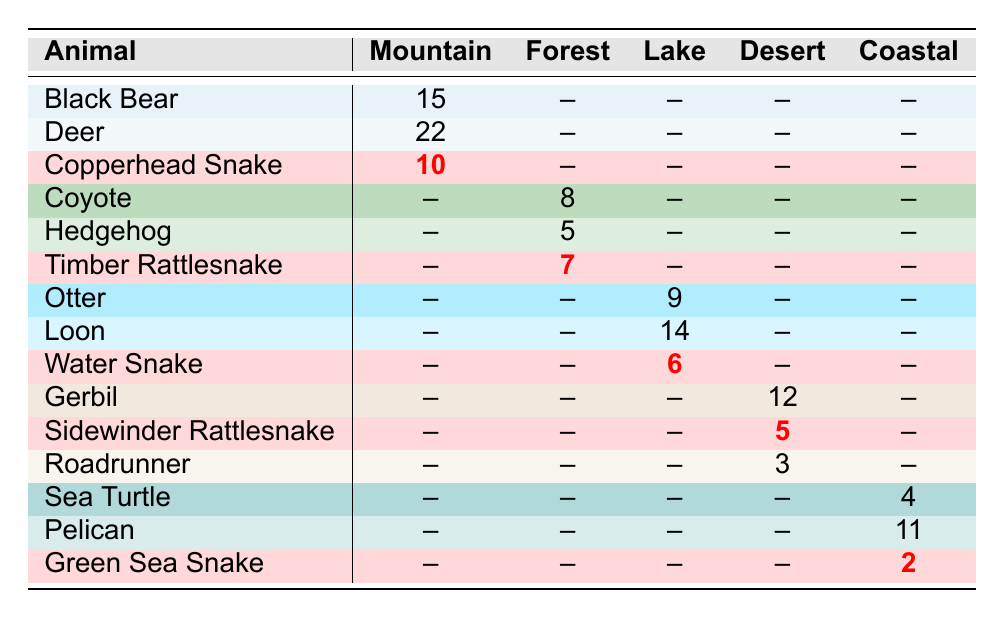What is the highest number of encounters with any type of animal in the Mountain terrain? According to the table, the highest encounter count in the Mountain terrain is 22 for Deer.
Answer: 22 How many encounters with snakes were reported in total across all terrains? The encounters with snakes are 10 (Copperhead Snake), 7 (Timber Rattlesnake), 6 (Water Snake), 5 (Sidewinder Rattlesnake), and 2 (Green Sea Snake). Summing these gives a total of 30 snake encounters.
Answer: 30 Is the encounter count for the Coyote in the Forest terrain greater than the encounter count for the Otter in the Lake terrain? The table shows 8 encounters with Coyote and 9 encounters with Otter. Since 8 is less than 9, the statement is false.
Answer: No What is the total number of animal encounters reported in the Lake terrain? The table lists 9 encounters with Otter and 14 encounters with Loon (Water Snake is not part of this terrain). Adding these gives a total of 23 encounters in the Lake terrain.
Answer: 23 How many more encounters were reported for Deer in the Mountain terrain compared to Hedgehog in the Forest terrain? The encounter counts show 22 for Deer and 5 for Hedgehog. The difference is 22 - 5 = 17.
Answer: 17 Are there more total encounters with animals in the Coastal terrain than in the Desert terrain? The Coastal terrain has 4 encounters (Sea Turtle) + 11 encounters (Pelican) + 2 encounters (Green Sea Snake) = 17. The Desert terrain has 12 encounters (Gerbil) + 5 encounters (Sidewinder Rattlesnake) + 3 encounters (Roadrunner) = 20. Since 17 is less than 20, the statement is false.
Answer: No What percentage of the encounters in the Mountain terrain are with snakes? In the Mountain terrain, there is a total of 47 encounters (15 Black Bear + 22 Deer + 10 Copperhead Snake). The count for snakes (Copperhead Snake) is 10. The percentage is (10 / 47) * 100 = approximately 21.28%.
Answer: 21.28% What is the average number of encounters reported for all terrains combined? To find the average, sum all encounters: 15 + 22 + 10 + 8 + 5 + 7 + 9 + 14 + 6 + 12 + 5 + 3 + 4 + 11 + 2 = 4 + 2 + 61 = 137. There are 15 animal types, so the average is 137 / 15 = approximately 9.13.
Answer: 9.13 What animal had the least encounters reported in the Coastal terrain? In the Coastal terrain, Sea Turtle has 4 encounters, Pelican has 11, and Green Sea Snake has 2. Therefore, the Green Sea Snake had the least encounters.
Answer: Green Sea Snake 